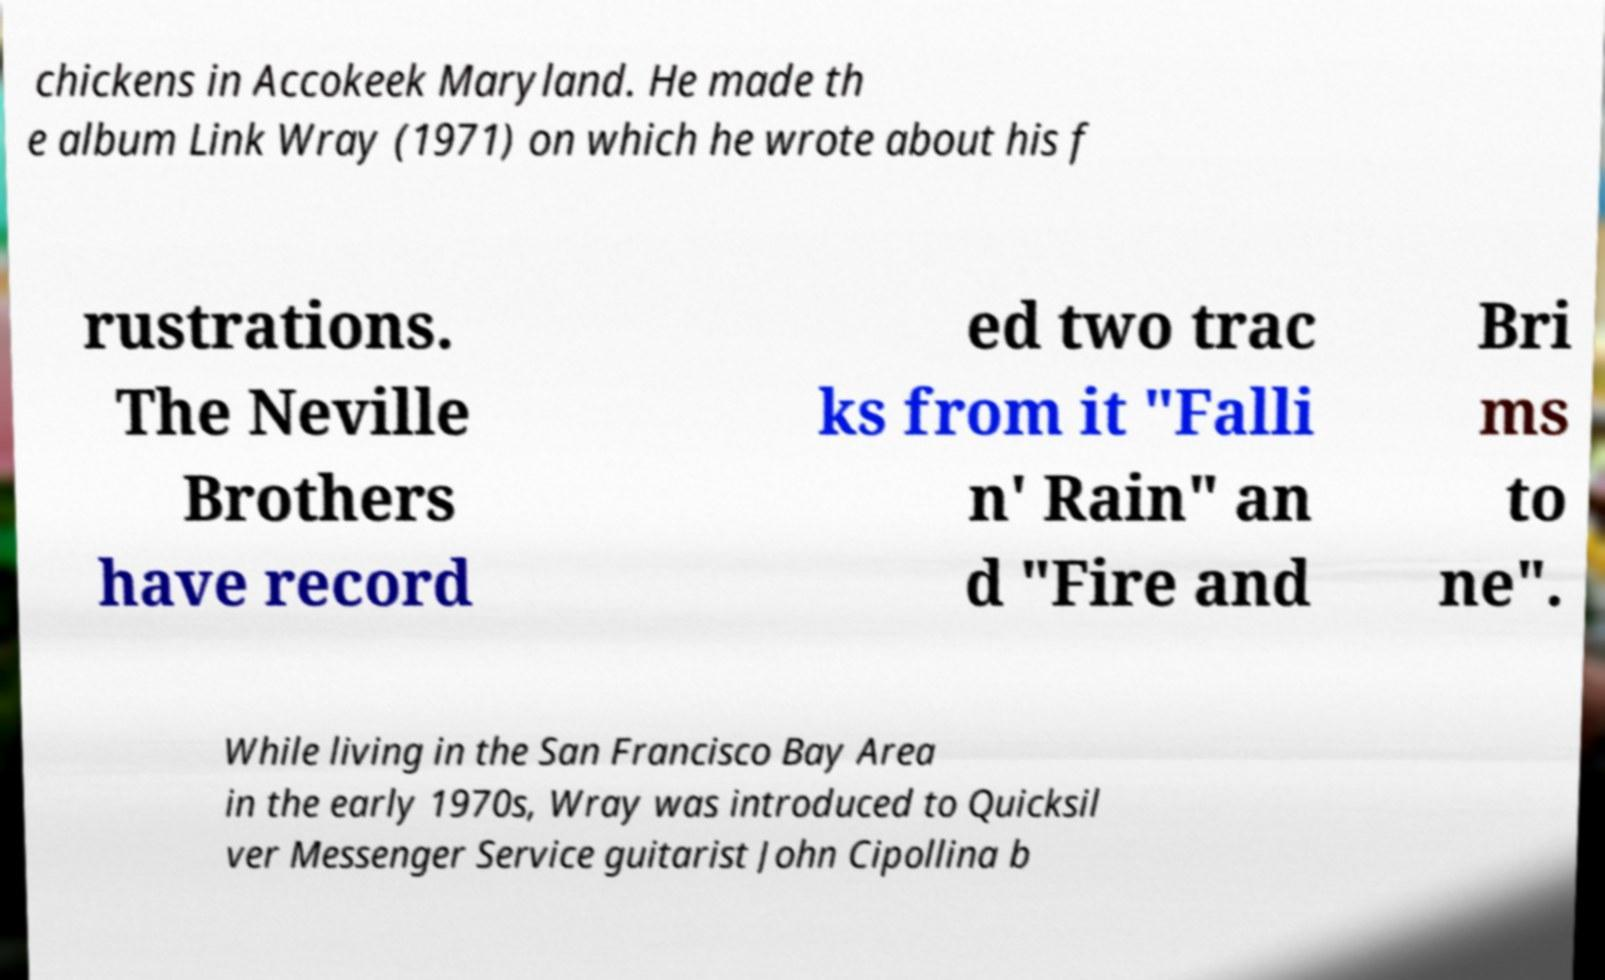Could you extract and type out the text from this image? chickens in Accokeek Maryland. He made th e album Link Wray (1971) on which he wrote about his f rustrations. The Neville Brothers have record ed two trac ks from it "Falli n' Rain" an d "Fire and Bri ms to ne". While living in the San Francisco Bay Area in the early 1970s, Wray was introduced to Quicksil ver Messenger Service guitarist John Cipollina b 